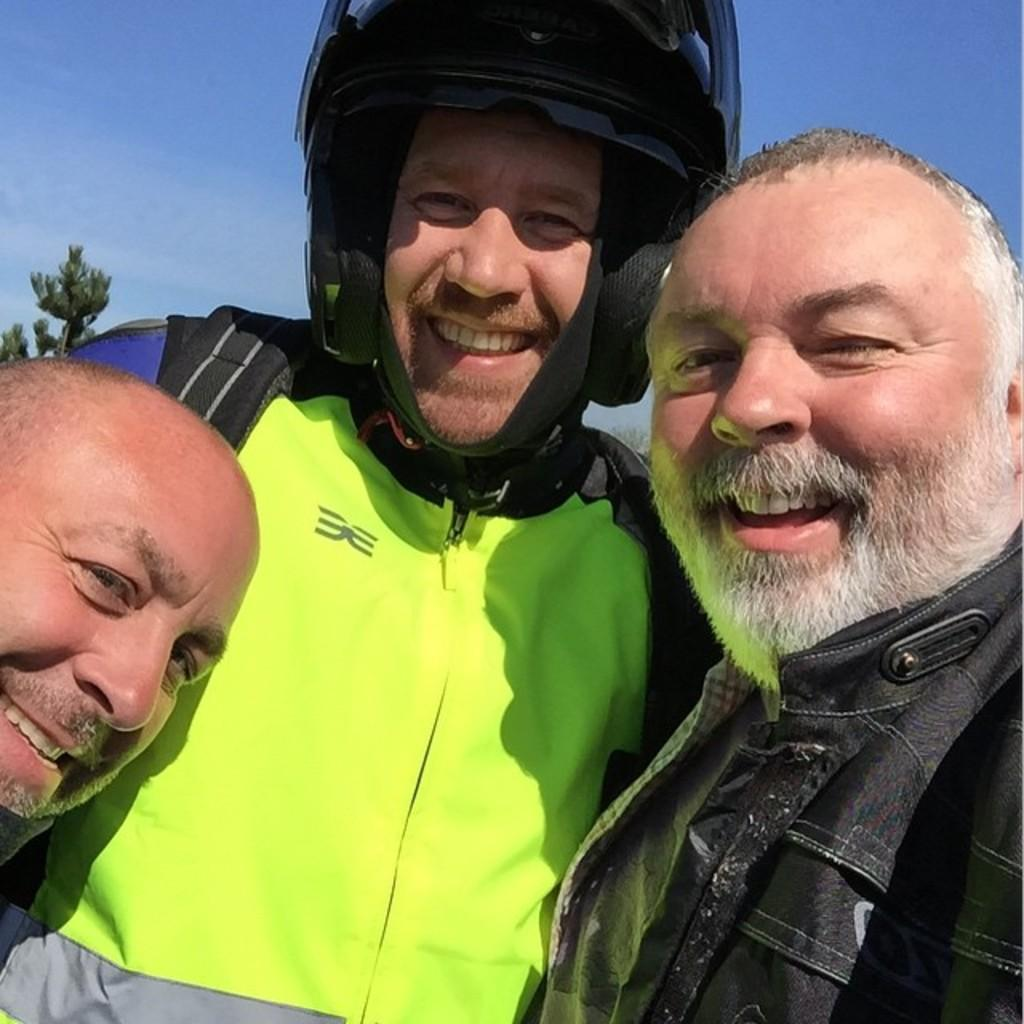Who is present in the image? There is a man in the image. What is the man doing in the image? The man is smiling in the image. What protective gear is the man wearing? The man is wearing a helmet in the image. What type of clothing is the man wearing? The man is wearing a coat in the image. Can you describe the coat visible on the right side of the image? There is a coat visible on the right side of the image, but no specific details about the coat are provided. What type of rice is being cooked in the oven in the image? There is no rice or oven present in the image; it features a man wearing a helmet and a coat. What tools might the carpenter be using in the image? There is no carpenter or tools present in the image; it features a man wearing a helmet and a coat. 